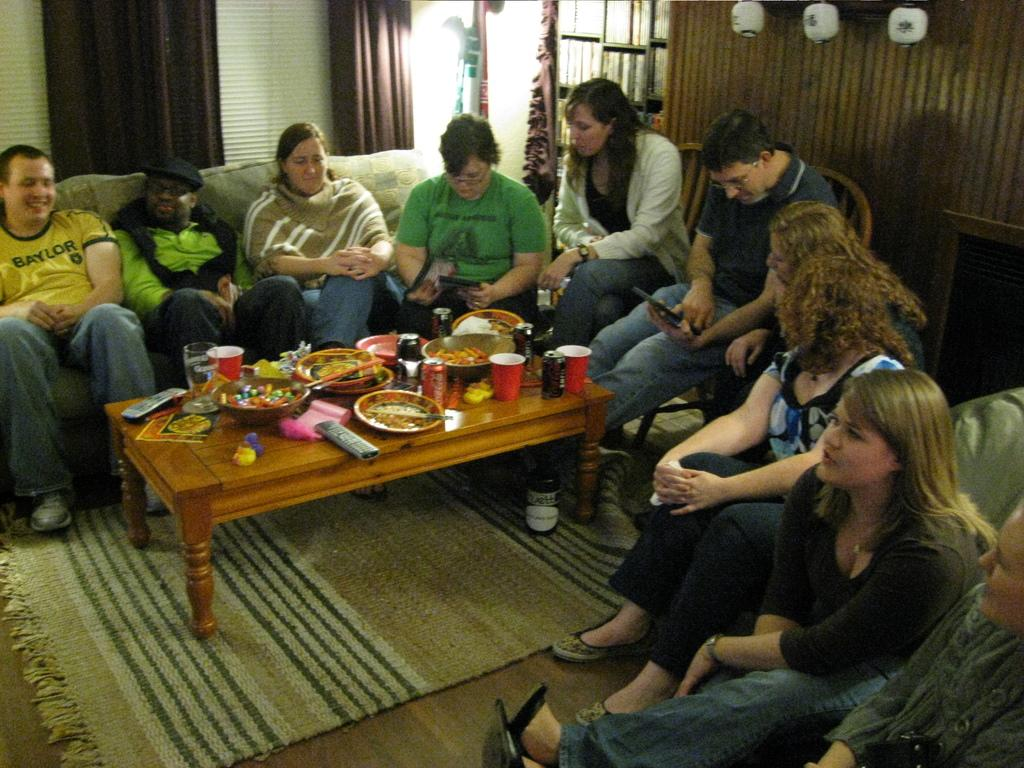How many people are in the image? There is a group of people in the image. What are the people doing in the image? The people are sitting on a couch and a chair. What can be seen on the table in the image? There are food items, a bowl, a plate, a cup, and a remote on the table. Where is the tub located in the image? There is no tub present in the image. What is the development stage of the geese in the image? There are no geese present in the image. 